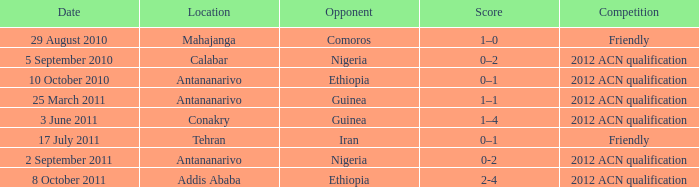Which competition was held at Addis Ababa? 2012 ACN qualification. 